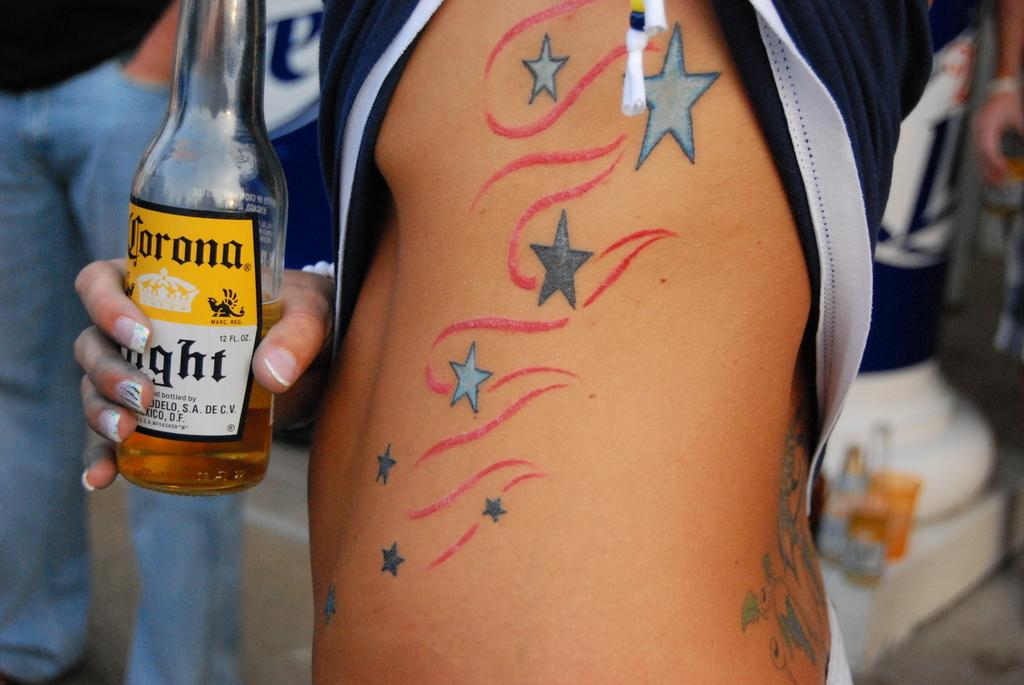What is the main subject of the image? There is a person's body in the image. What can be seen on the person's body? The person has a tattoo on their body. What is the person holding in their hand? The person is holding a bottle in their hand. Can you describe the background of the image? There are people standing in the background of the image. What type of mask is being distributed to the people in the image? There is no mask or distribution activity present in the image. 